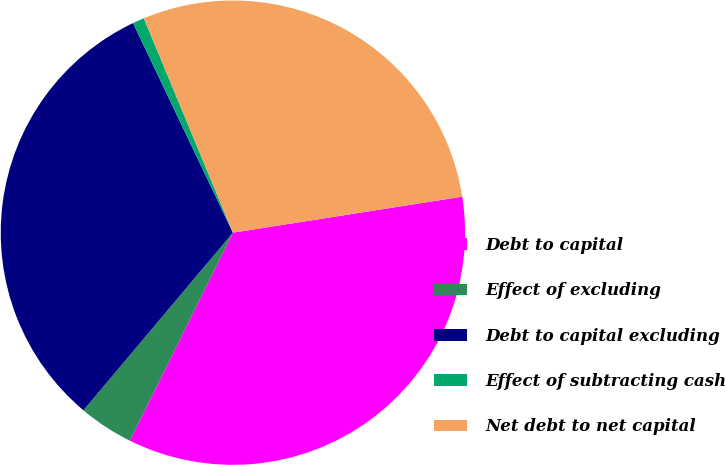<chart> <loc_0><loc_0><loc_500><loc_500><pie_chart><fcel>Debt to capital<fcel>Effect of excluding<fcel>Debt to capital excluding<fcel>Effect of subtracting cash<fcel>Net debt to net capital<nl><fcel>34.8%<fcel>3.81%<fcel>31.79%<fcel>0.81%<fcel>28.79%<nl></chart> 